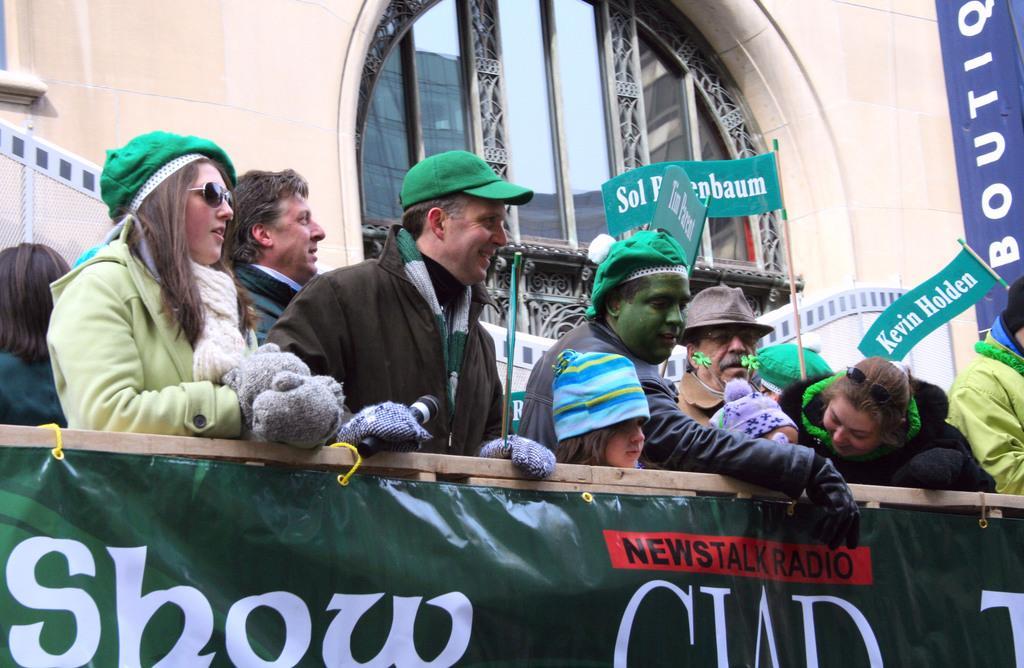Describe this image in one or two sentences. In this image I can see there are few people standing here and they are wearing green color caps and there is a banner and in the backdrop there is a building. 